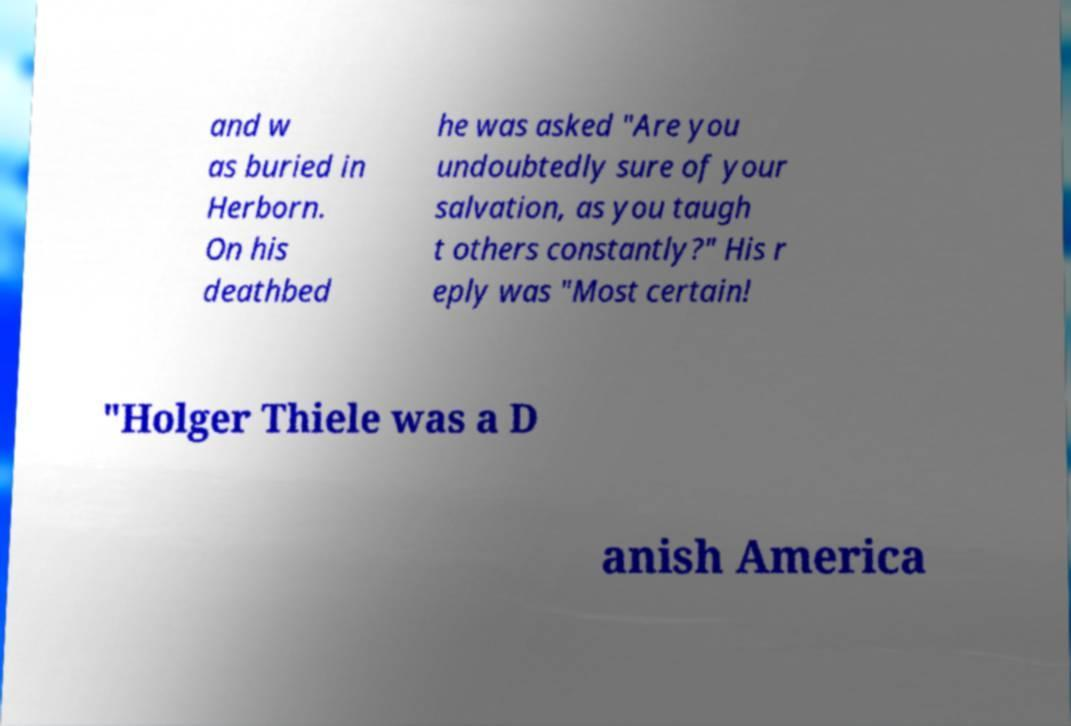Please identify and transcribe the text found in this image. and w as buried in Herborn. On his deathbed he was asked "Are you undoubtedly sure of your salvation, as you taugh t others constantly?" His r eply was "Most certain! "Holger Thiele was a D anish America 